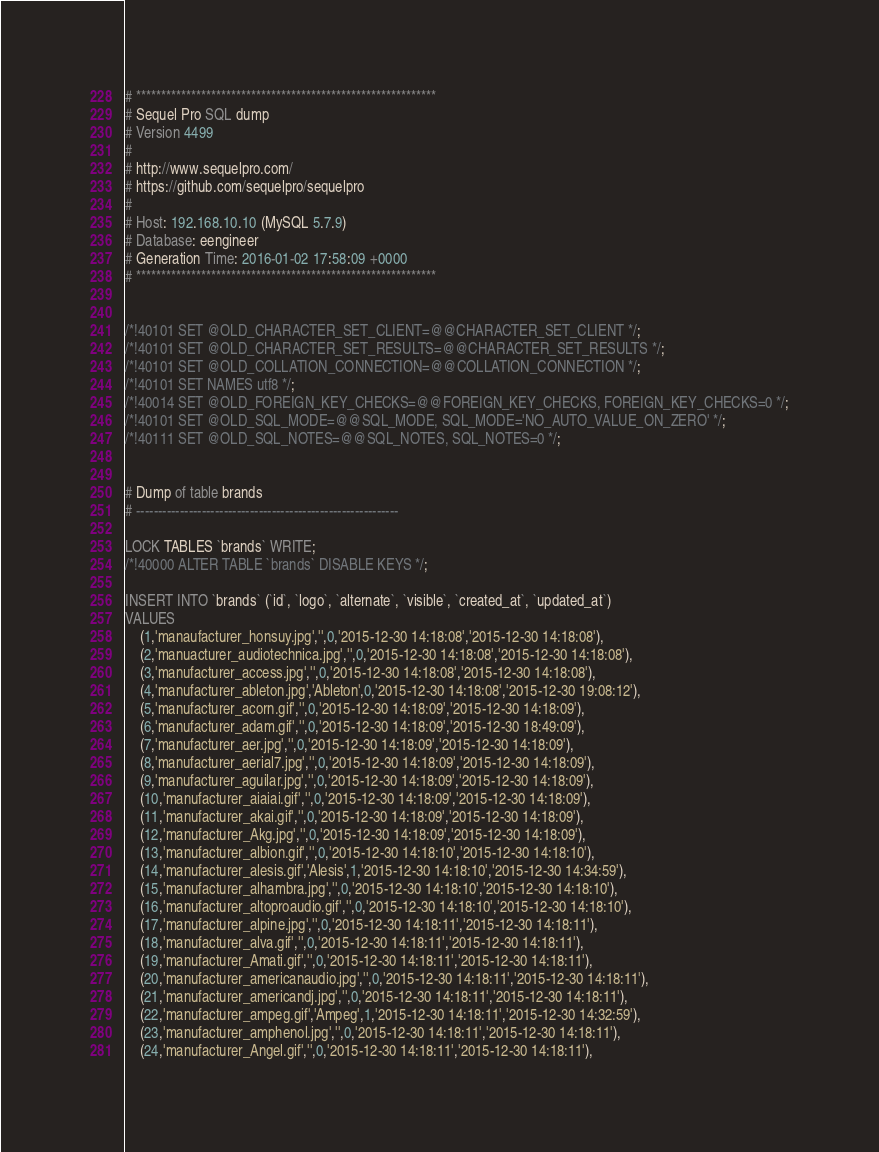<code> <loc_0><loc_0><loc_500><loc_500><_SQL_># ************************************************************
# Sequel Pro SQL dump
# Version 4499
#
# http://www.sequelpro.com/
# https://github.com/sequelpro/sequelpro
#
# Host: 192.168.10.10 (MySQL 5.7.9)
# Database: eengineer
# Generation Time: 2016-01-02 17:58:09 +0000
# ************************************************************


/*!40101 SET @OLD_CHARACTER_SET_CLIENT=@@CHARACTER_SET_CLIENT */;
/*!40101 SET @OLD_CHARACTER_SET_RESULTS=@@CHARACTER_SET_RESULTS */;
/*!40101 SET @OLD_COLLATION_CONNECTION=@@COLLATION_CONNECTION */;
/*!40101 SET NAMES utf8 */;
/*!40014 SET @OLD_FOREIGN_KEY_CHECKS=@@FOREIGN_KEY_CHECKS, FOREIGN_KEY_CHECKS=0 */;
/*!40101 SET @OLD_SQL_MODE=@@SQL_MODE, SQL_MODE='NO_AUTO_VALUE_ON_ZERO' */;
/*!40111 SET @OLD_SQL_NOTES=@@SQL_NOTES, SQL_NOTES=0 */;


# Dump of table brands
# ------------------------------------------------------------

LOCK TABLES `brands` WRITE;
/*!40000 ALTER TABLE `brands` DISABLE KEYS */;

INSERT INTO `brands` (`id`, `logo`, `alternate`, `visible`, `created_at`, `updated_at`)
VALUES
	(1,'manaufacturer_honsuy.jpg','',0,'2015-12-30 14:18:08','2015-12-30 14:18:08'),
	(2,'manuacturer_audiotechnica.jpg','',0,'2015-12-30 14:18:08','2015-12-30 14:18:08'),
	(3,'manufacturer_access.jpg','',0,'2015-12-30 14:18:08','2015-12-30 14:18:08'),
	(4,'manufacturer_ableton.jpg','Ableton',0,'2015-12-30 14:18:08','2015-12-30 19:08:12'),
	(5,'manufacturer_acorn.gif','',0,'2015-12-30 14:18:09','2015-12-30 14:18:09'),
	(6,'manufacturer_adam.gif','',0,'2015-12-30 14:18:09','2015-12-30 18:49:09'),
	(7,'manufacturer_aer.jpg','',0,'2015-12-30 14:18:09','2015-12-30 14:18:09'),
	(8,'manufacturer_aerial7.jpg','',0,'2015-12-30 14:18:09','2015-12-30 14:18:09'),
	(9,'manufacturer_aguilar.jpg','',0,'2015-12-30 14:18:09','2015-12-30 14:18:09'),
	(10,'manufacturer_aiaiai.gif','',0,'2015-12-30 14:18:09','2015-12-30 14:18:09'),
	(11,'manufacturer_akai.gif','',0,'2015-12-30 14:18:09','2015-12-30 14:18:09'),
	(12,'manufacturer_Akg.jpg','',0,'2015-12-30 14:18:09','2015-12-30 14:18:09'),
	(13,'manufacturer_albion.gif','',0,'2015-12-30 14:18:10','2015-12-30 14:18:10'),
	(14,'manufacturer_alesis.gif','Alesis',1,'2015-12-30 14:18:10','2015-12-30 14:34:59'),
	(15,'manufacturer_alhambra.jpg','',0,'2015-12-30 14:18:10','2015-12-30 14:18:10'),
	(16,'manufacturer_altoproaudio.gif','',0,'2015-12-30 14:18:10','2015-12-30 14:18:10'),
	(17,'manufacturer_alpine.jpg','',0,'2015-12-30 14:18:11','2015-12-30 14:18:11'),
	(18,'manufacturer_alva.gif','',0,'2015-12-30 14:18:11','2015-12-30 14:18:11'),
	(19,'manufacturer_Amati.gif','',0,'2015-12-30 14:18:11','2015-12-30 14:18:11'),
	(20,'manufacturer_americanaudio.jpg','',0,'2015-12-30 14:18:11','2015-12-30 14:18:11'),
	(21,'manufacturer_americandj.jpg','',0,'2015-12-30 14:18:11','2015-12-30 14:18:11'),
	(22,'manufacturer_ampeg.gif','Ampeg',1,'2015-12-30 14:18:11','2015-12-30 14:32:59'),
	(23,'manufacturer_amphenol.jpg','',0,'2015-12-30 14:18:11','2015-12-30 14:18:11'),
	(24,'manufacturer_Angel.gif','',0,'2015-12-30 14:18:11','2015-12-30 14:18:11'),</code> 